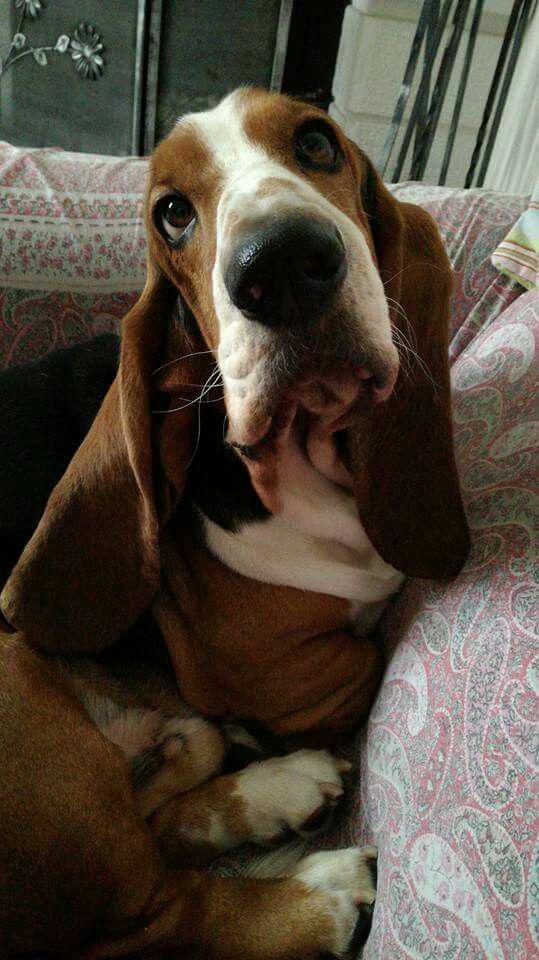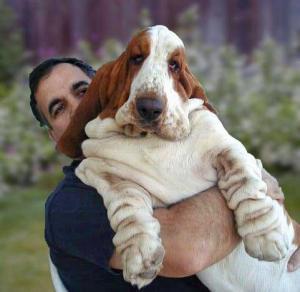The first image is the image on the left, the second image is the image on the right. For the images shown, is this caption "At least one image contains a human being." true? Answer yes or no. Yes. The first image is the image on the left, the second image is the image on the right. Considering the images on both sides, is "There is a droopy dog being held by a person in one image, and a droopy dog with no person in the other." valid? Answer yes or no. Yes. 